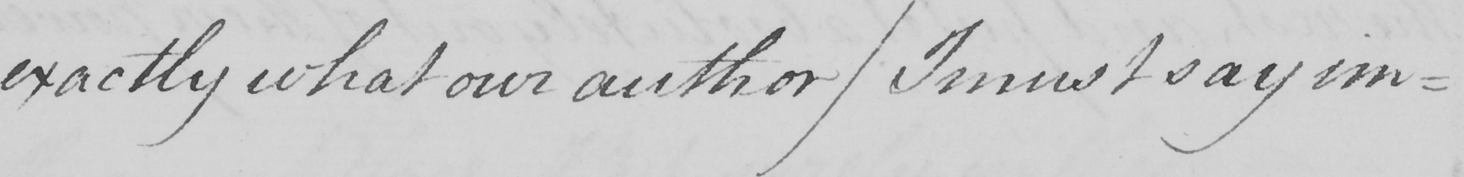What is written in this line of handwriting? exactly what our author  ( I must say im- 